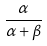Convert formula to latex. <formula><loc_0><loc_0><loc_500><loc_500>\frac { \alpha } { \alpha + \beta }</formula> 